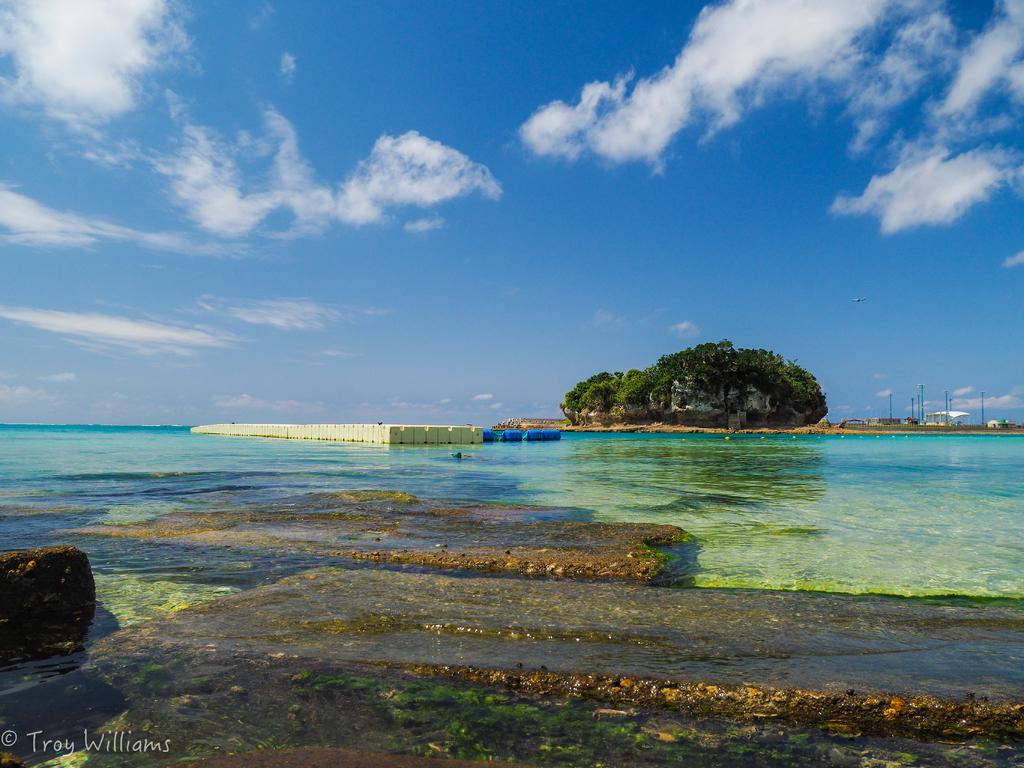What is the main subject in the center of the image? There is water in the center of the image. What can be seen in the background of the image? The sky, clouds, trees, and poles are visible in the background of the image. Is there any text or marking in the image? Yes, there is a watermark in the bottom left of the image. What type of structure is present in the image? There is a wall in the image. What type of glove is the grandfather wearing in the image? There is no grandfather or glove present in the image. How many family members can be seen in the image? There are no family members present in the image. 